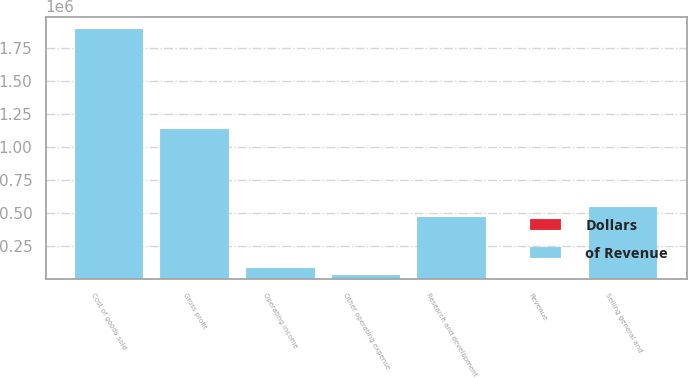Convert chart to OTSL. <chart><loc_0><loc_0><loc_500><loc_500><stacked_bar_chart><ecel><fcel>Revenue<fcel>Cost of goods sold<fcel>Gross profit<fcel>Research and development<fcel>Selling general and<fcel>Other operating expense<fcel>Operating income<nl><fcel>of Revenue<fcel>100<fcel>1.89706e+06<fcel>1.13551e+06<fcel>470836<fcel>545588<fcel>31029<fcel>88059<nl><fcel>Dollars<fcel>100<fcel>62.6<fcel>37.4<fcel>15.5<fcel>18<fcel>1<fcel>2.9<nl></chart> 